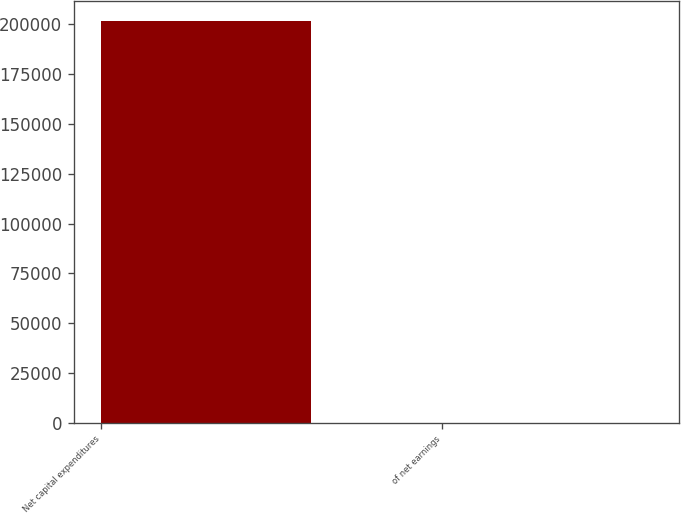Convert chart. <chart><loc_0><loc_0><loc_500><loc_500><bar_chart><fcel>Net capital expenditures<fcel>of net earnings<nl><fcel>201550<fcel>44.9<nl></chart> 